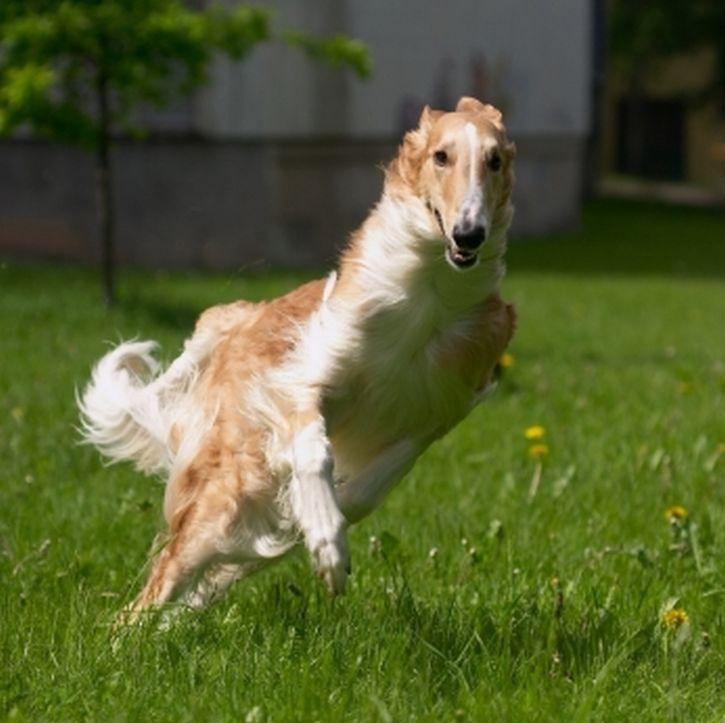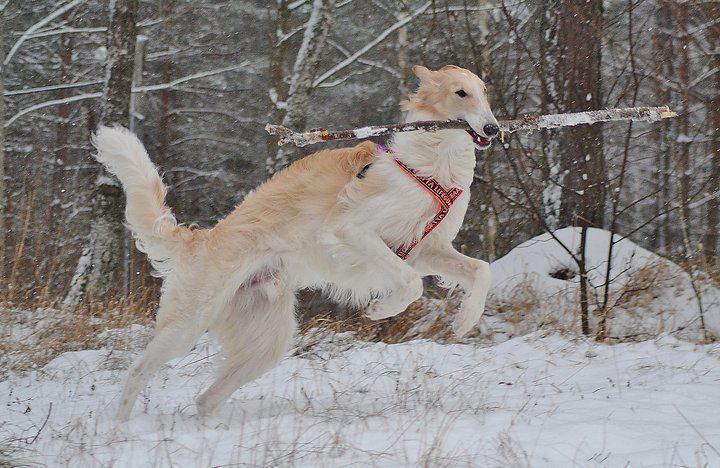The first image is the image on the left, the second image is the image on the right. Examine the images to the left and right. Is the description "The right image contains at least one dog that is surrounded by snow." accurate? Answer yes or no. Yes. The first image is the image on the left, the second image is the image on the right. Considering the images on both sides, is "Each image features one bounding dog, with one image showing a dog on a beach and the other a dog on a grassy field." valid? Answer yes or no. No. 